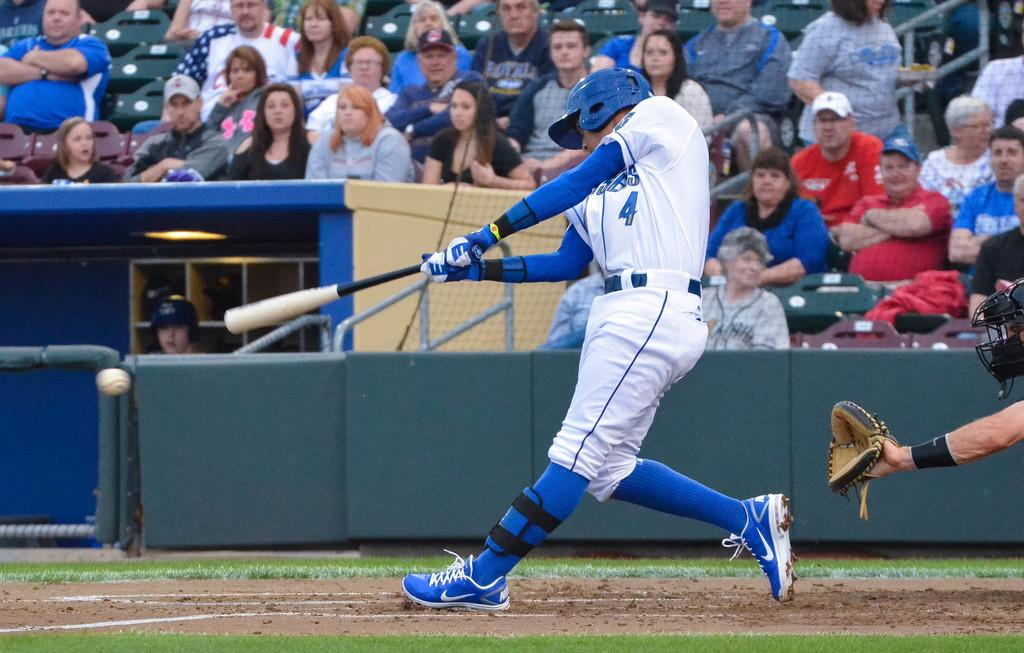What is the person in the center of the image holding? The person is holding a bat. What can be seen in the background of the image? There is a fence, a shelf, a light, people sitting, and other objects present in the background of the image. Can you describe the setting of the image? The person holding the bat is standing in the center of the image, with a fence, a shelf, a light, and people sitting visible in the background. What type of writing can be seen on the bat in the image? There is no writing visible on the bat in the image. What is the weather like in the image? The provided facts do not mention the weather or time of day, so it cannot be determined from the image. 